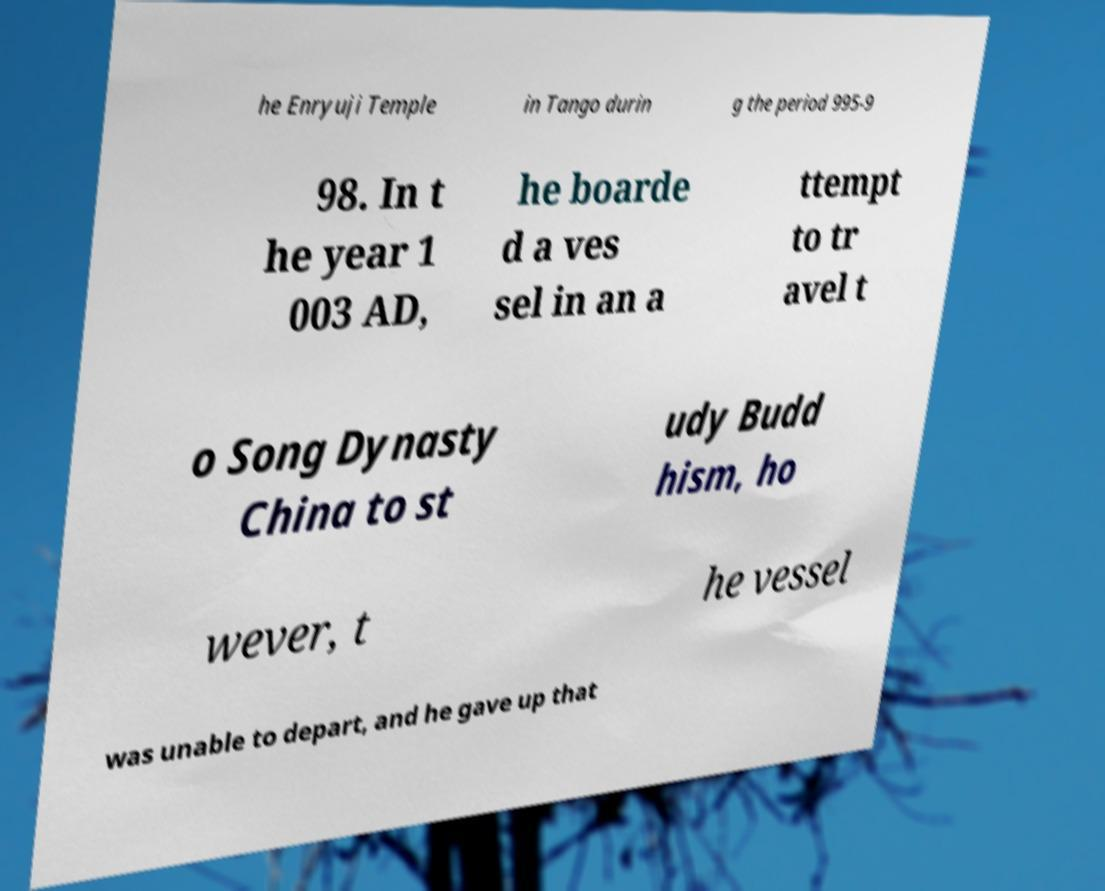For documentation purposes, I need the text within this image transcribed. Could you provide that? he Enryuji Temple in Tango durin g the period 995-9 98. In t he year 1 003 AD, he boarde d a ves sel in an a ttempt to tr avel t o Song Dynasty China to st udy Budd hism, ho wever, t he vessel was unable to depart, and he gave up that 